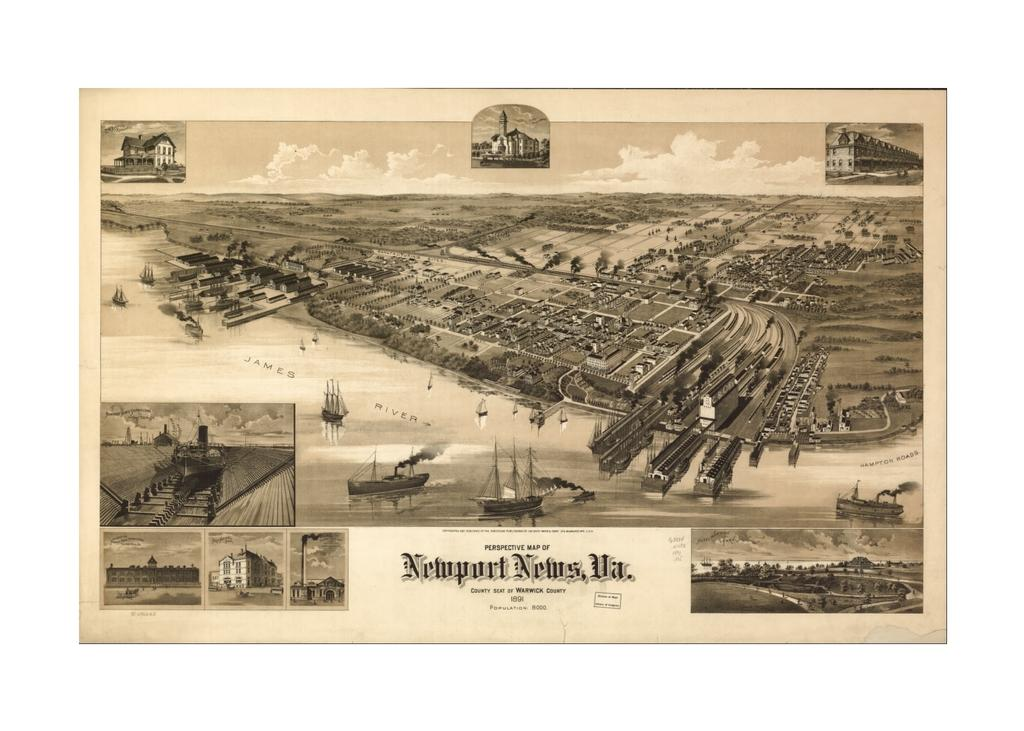Provide a one-sentence caption for the provided image. An old poster of a beachfront area, printed by newport News. 